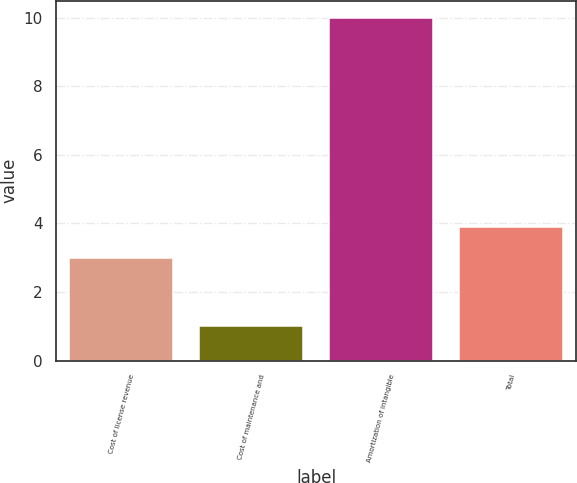Convert chart. <chart><loc_0><loc_0><loc_500><loc_500><bar_chart><fcel>Cost of license revenue<fcel>Cost of maintenance and<fcel>Amortization of intangible<fcel>Total<nl><fcel>3<fcel>1<fcel>10<fcel>3.9<nl></chart> 